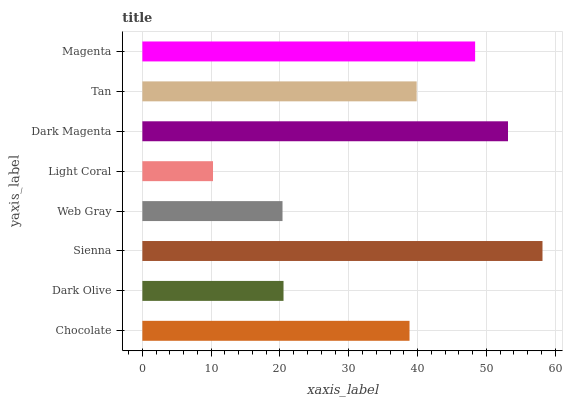Is Light Coral the minimum?
Answer yes or no. Yes. Is Sienna the maximum?
Answer yes or no. Yes. Is Dark Olive the minimum?
Answer yes or no. No. Is Dark Olive the maximum?
Answer yes or no. No. Is Chocolate greater than Dark Olive?
Answer yes or no. Yes. Is Dark Olive less than Chocolate?
Answer yes or no. Yes. Is Dark Olive greater than Chocolate?
Answer yes or no. No. Is Chocolate less than Dark Olive?
Answer yes or no. No. Is Tan the high median?
Answer yes or no. Yes. Is Chocolate the low median?
Answer yes or no. Yes. Is Sienna the high median?
Answer yes or no. No. Is Web Gray the low median?
Answer yes or no. No. 